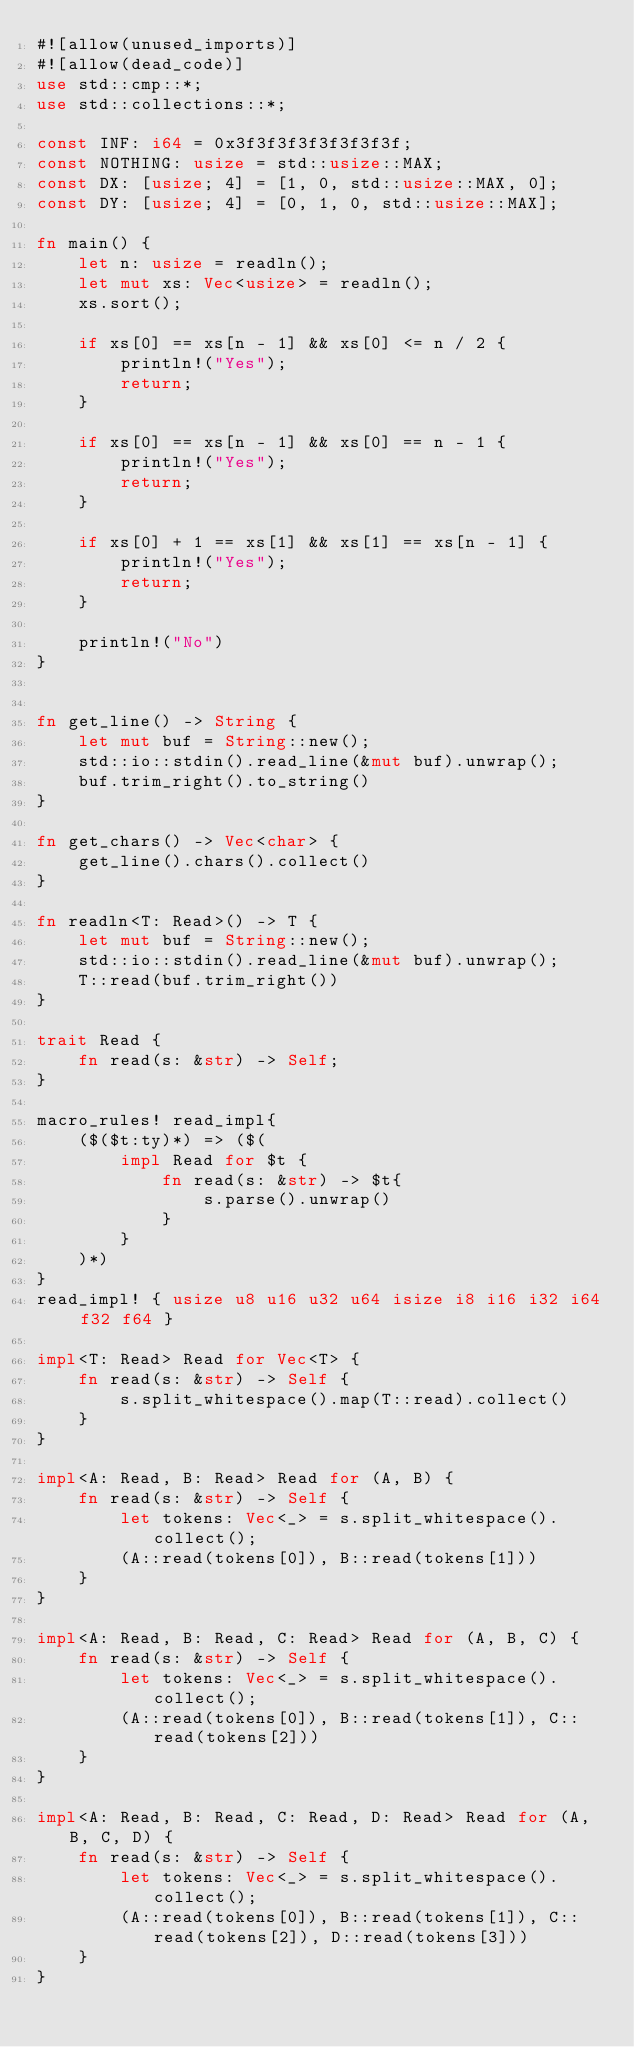<code> <loc_0><loc_0><loc_500><loc_500><_Rust_>#![allow(unused_imports)]
#![allow(dead_code)]
use std::cmp::*;
use std::collections::*;

const INF: i64 = 0x3f3f3f3f3f3f3f3f;
const NOTHING: usize = std::usize::MAX;
const DX: [usize; 4] = [1, 0, std::usize::MAX, 0];
const DY: [usize; 4] = [0, 1, 0, std::usize::MAX];

fn main() {
    let n: usize = readln();
    let mut xs: Vec<usize> = readln();
    xs.sort();

    if xs[0] == xs[n - 1] && xs[0] <= n / 2 {
        println!("Yes");
        return;
    }

    if xs[0] == xs[n - 1] && xs[0] == n - 1 {
        println!("Yes");
        return;
    }

    if xs[0] + 1 == xs[1] && xs[1] == xs[n - 1] {
        println!("Yes");
        return;
    }

    println!("No")
}


fn get_line() -> String {
    let mut buf = String::new();
    std::io::stdin().read_line(&mut buf).unwrap();
    buf.trim_right().to_string()
}

fn get_chars() -> Vec<char> {
    get_line().chars().collect()
}

fn readln<T: Read>() -> T {
    let mut buf = String::new();
    std::io::stdin().read_line(&mut buf).unwrap();
    T::read(buf.trim_right())
}

trait Read {
    fn read(s: &str) -> Self;
}

macro_rules! read_impl{
    ($($t:ty)*) => ($(
        impl Read for $t {
            fn read(s: &str) -> $t{
                s.parse().unwrap()
            }
        }
    )*)
}
read_impl! { usize u8 u16 u32 u64 isize i8 i16 i32 i64 f32 f64 }

impl<T: Read> Read for Vec<T> {
    fn read(s: &str) -> Self {
        s.split_whitespace().map(T::read).collect()
    }
}

impl<A: Read, B: Read> Read for (A, B) {
    fn read(s: &str) -> Self {
        let tokens: Vec<_> = s.split_whitespace().collect();
        (A::read(tokens[0]), B::read(tokens[1]))
    }
}

impl<A: Read, B: Read, C: Read> Read for (A, B, C) {
    fn read(s: &str) -> Self {
        let tokens: Vec<_> = s.split_whitespace().collect();
        (A::read(tokens[0]), B::read(tokens[1]), C::read(tokens[2]))
    }
}

impl<A: Read, B: Read, C: Read, D: Read> Read for (A, B, C, D) {
    fn read(s: &str) -> Self {
        let tokens: Vec<_> = s.split_whitespace().collect();
        (A::read(tokens[0]), B::read(tokens[1]), C::read(tokens[2]), D::read(tokens[3]))
    }
}</code> 